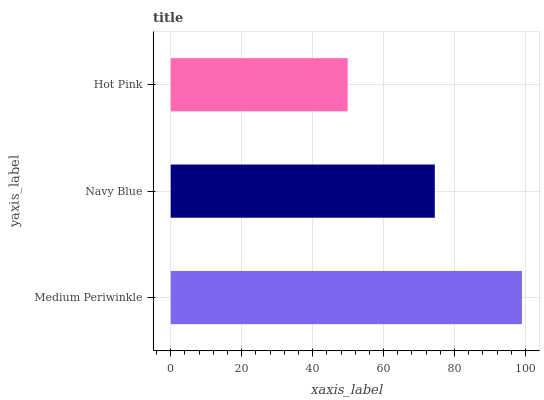Is Hot Pink the minimum?
Answer yes or no. Yes. Is Medium Periwinkle the maximum?
Answer yes or no. Yes. Is Navy Blue the minimum?
Answer yes or no. No. Is Navy Blue the maximum?
Answer yes or no. No. Is Medium Periwinkle greater than Navy Blue?
Answer yes or no. Yes. Is Navy Blue less than Medium Periwinkle?
Answer yes or no. Yes. Is Navy Blue greater than Medium Periwinkle?
Answer yes or no. No. Is Medium Periwinkle less than Navy Blue?
Answer yes or no. No. Is Navy Blue the high median?
Answer yes or no. Yes. Is Navy Blue the low median?
Answer yes or no. Yes. Is Hot Pink the high median?
Answer yes or no. No. Is Medium Periwinkle the low median?
Answer yes or no. No. 